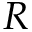Convert formula to latex. <formula><loc_0><loc_0><loc_500><loc_500>R</formula> 